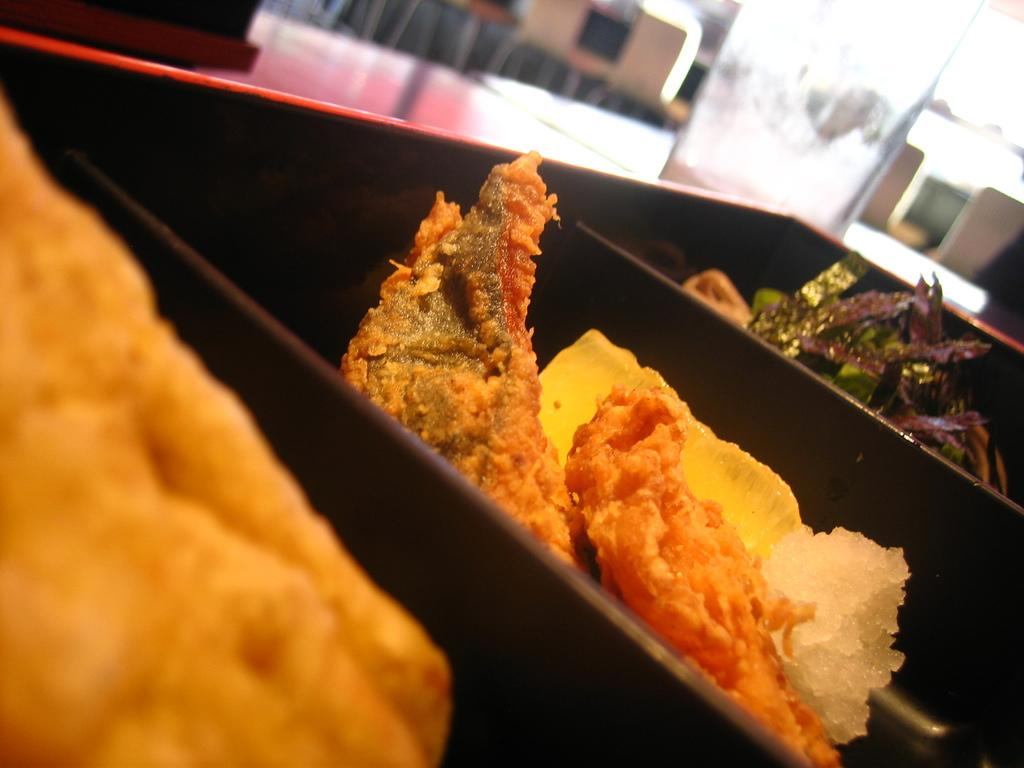What objects are in the foreground of the image? There are plates in the foreground of the image. What is on the plates? There are food items on the plates. What can be seen in the background of the image? There is a table, a glass, and chairs in the background of the image. What type of pest can be seen crawling on the table in the image? There is no pest visible in the image; the table is clear of any such creatures. 